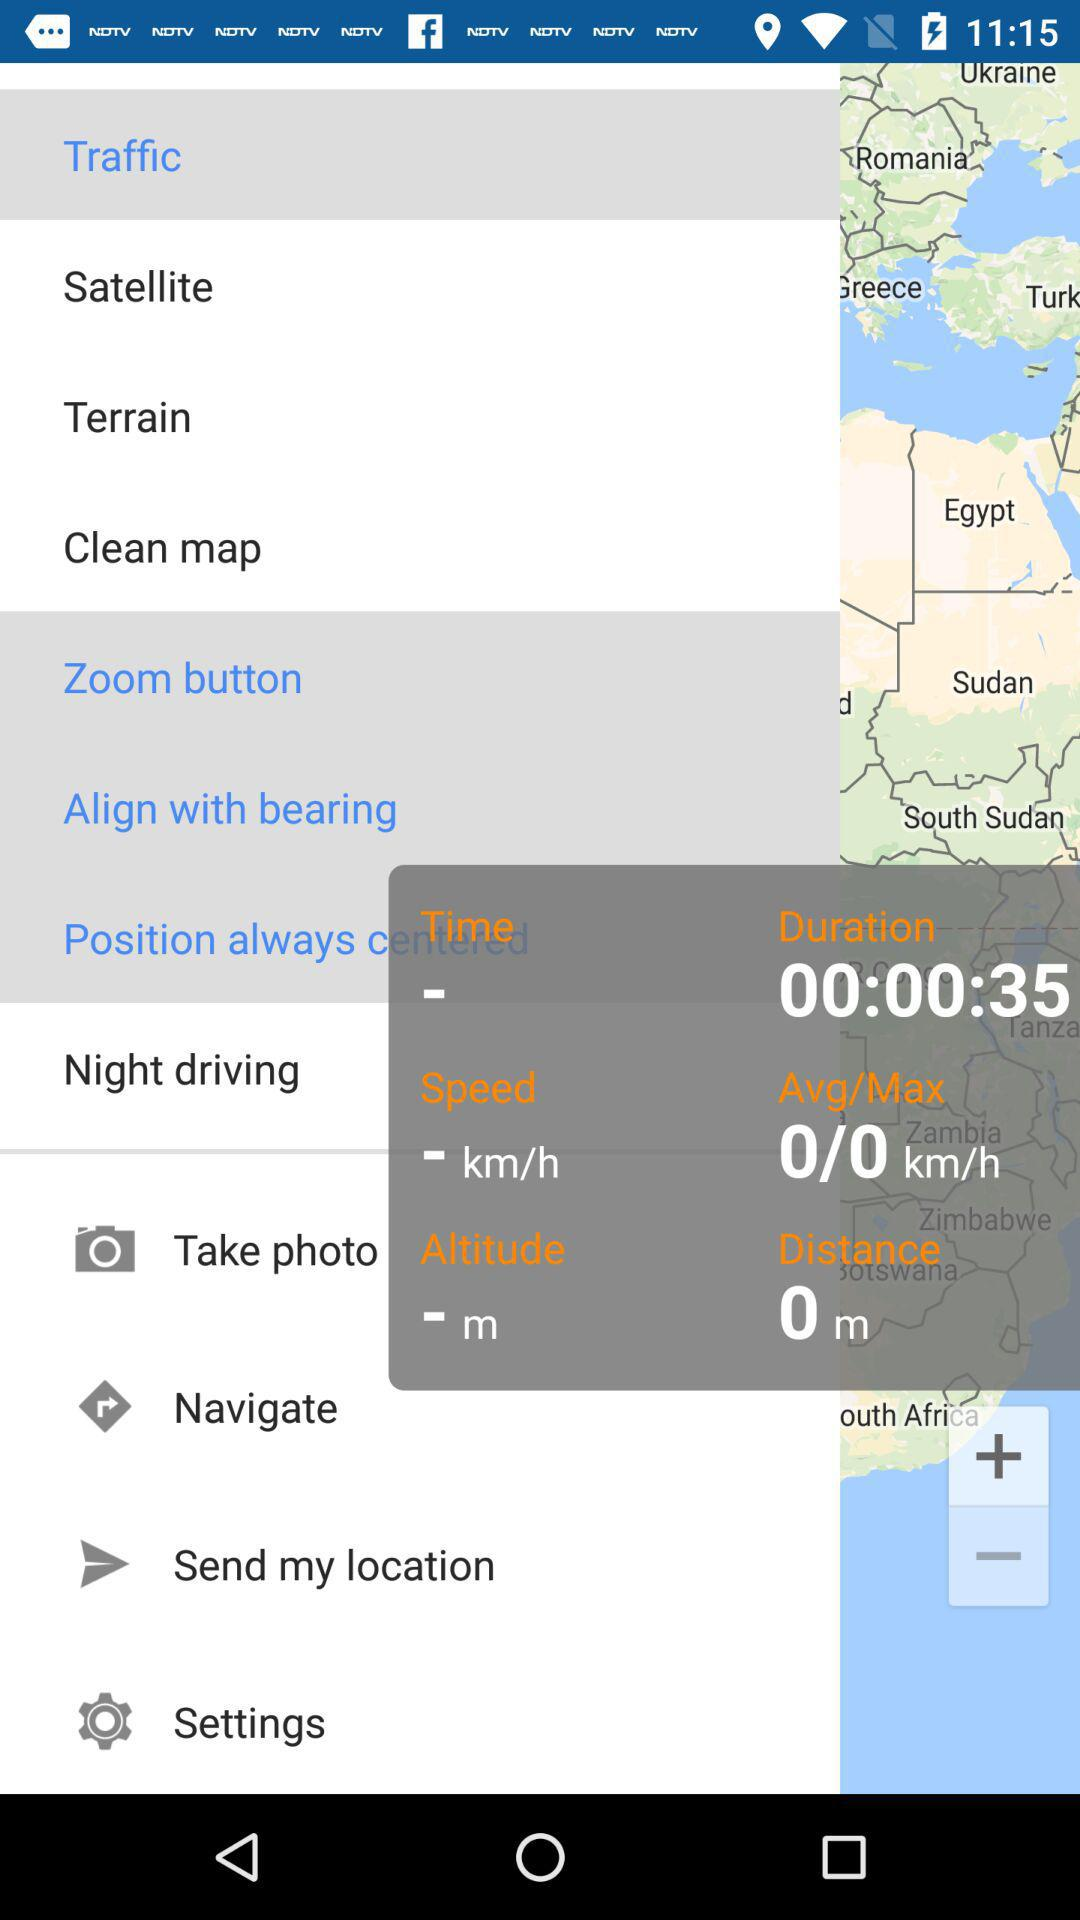What is the time duration? The time duration is 35 seconds. 